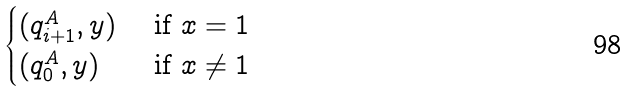Convert formula to latex. <formula><loc_0><loc_0><loc_500><loc_500>\begin{cases} ( q ^ { A } _ { i + 1 } , y ) & \text { if } x = 1 \\ ( q ^ { A } _ { 0 } , y ) & \text { if } x \ne 1 \\ \end{cases}</formula> 